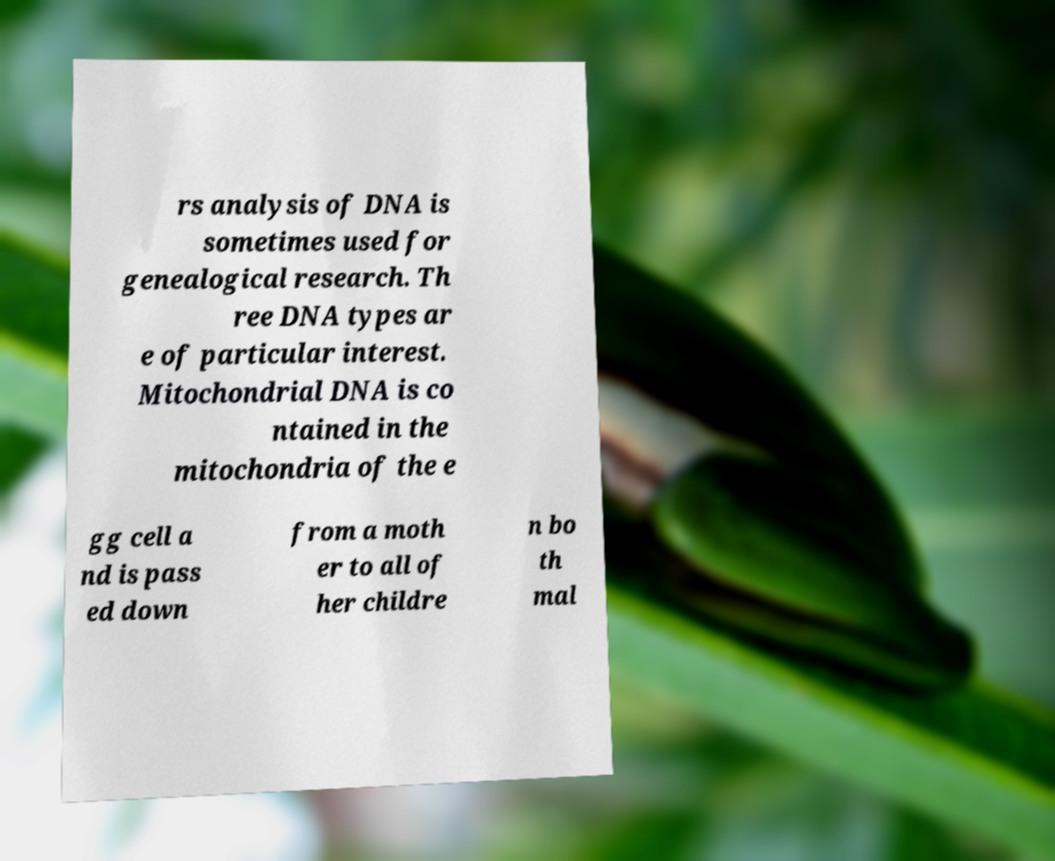What messages or text are displayed in this image? I need them in a readable, typed format. rs analysis of DNA is sometimes used for genealogical research. Th ree DNA types ar e of particular interest. Mitochondrial DNA is co ntained in the mitochondria of the e gg cell a nd is pass ed down from a moth er to all of her childre n bo th mal 